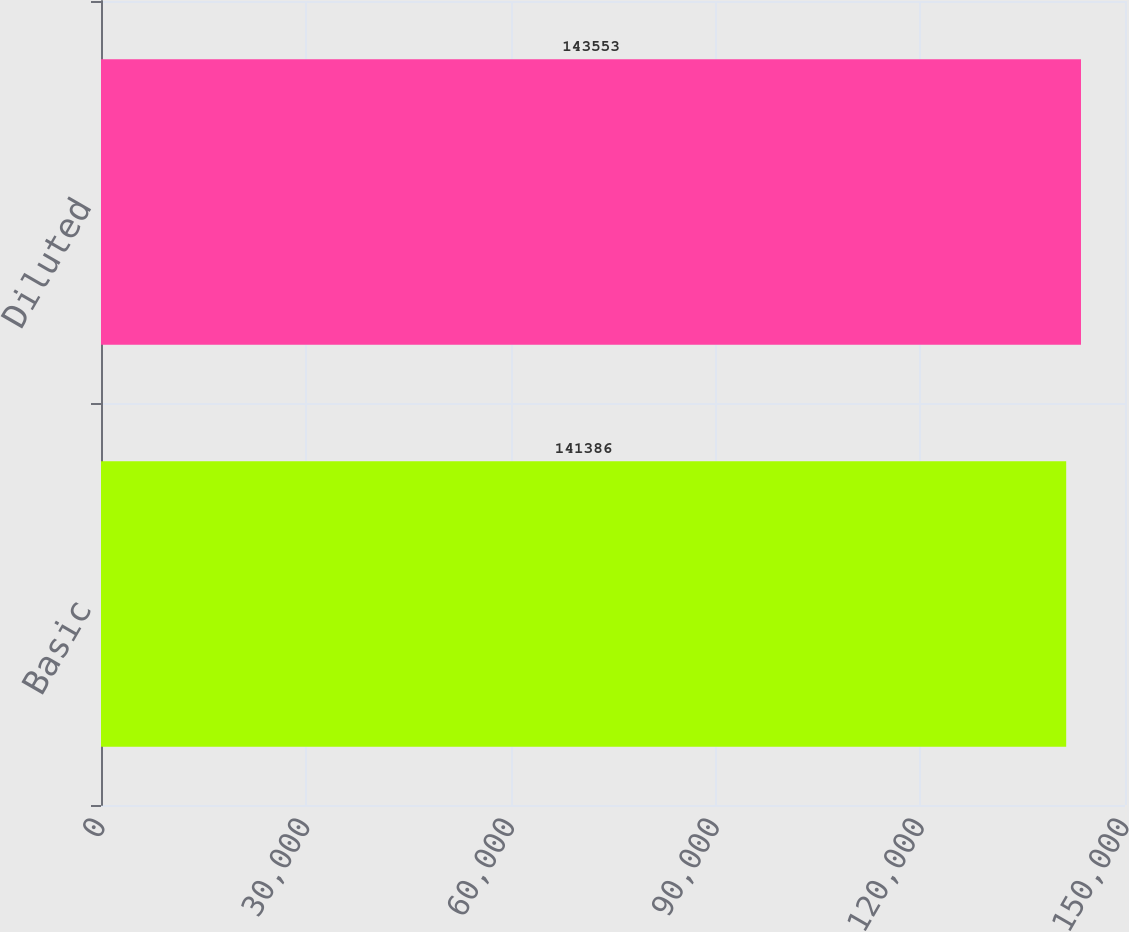Convert chart to OTSL. <chart><loc_0><loc_0><loc_500><loc_500><bar_chart><fcel>Basic<fcel>Diluted<nl><fcel>141386<fcel>143553<nl></chart> 